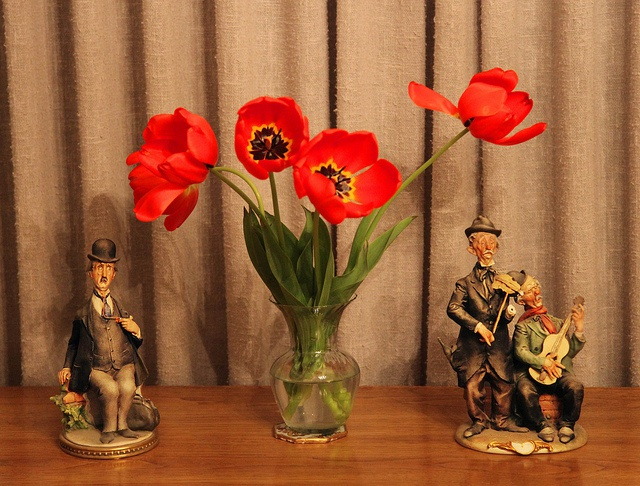Describe the objects in this image and their specific colors. I can see potted plant in maroon, red, olive, black, and tan tones, dining table in maroon and brown tones, and vase in maroon, olive, and black tones in this image. 